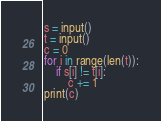Convert code to text. <code><loc_0><loc_0><loc_500><loc_500><_Python_>s = input()
t = input()
c = 0
for i in range(len(t)):
    if s[i] != t[i]:
        c += 1
print(c)
</code> 